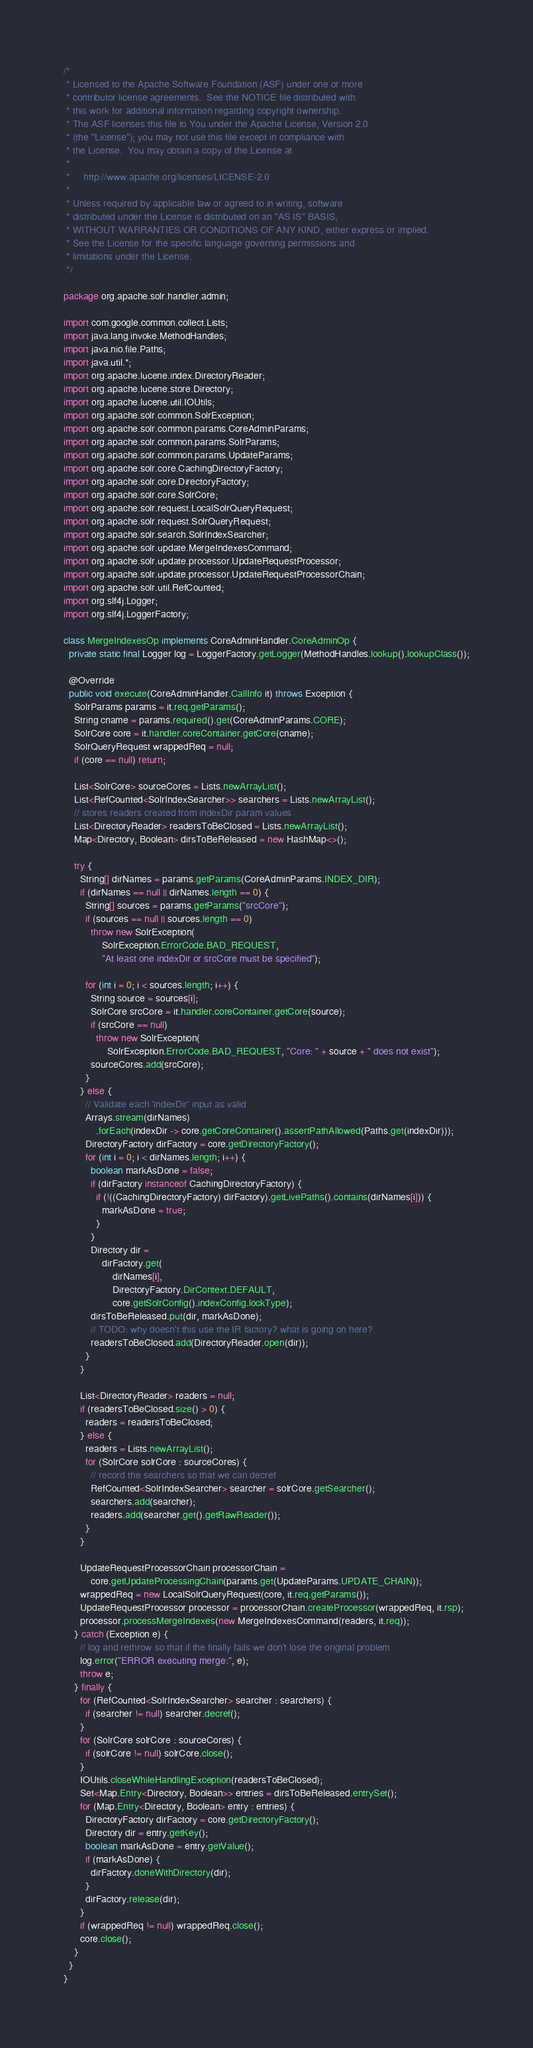<code> <loc_0><loc_0><loc_500><loc_500><_Java_>/*
 * Licensed to the Apache Software Foundation (ASF) under one or more
 * contributor license agreements.  See the NOTICE file distributed with
 * this work for additional information regarding copyright ownership.
 * The ASF licenses this file to You under the Apache License, Version 2.0
 * (the "License"); you may not use this file except in compliance with
 * the License.  You may obtain a copy of the License at
 *
 *     http://www.apache.org/licenses/LICENSE-2.0
 *
 * Unless required by applicable law or agreed to in writing, software
 * distributed under the License is distributed on an "AS IS" BASIS,
 * WITHOUT WARRANTIES OR CONDITIONS OF ANY KIND, either express or implied.
 * See the License for the specific language governing permissions and
 * limitations under the License.
 */

package org.apache.solr.handler.admin;

import com.google.common.collect.Lists;
import java.lang.invoke.MethodHandles;
import java.nio.file.Paths;
import java.util.*;
import org.apache.lucene.index.DirectoryReader;
import org.apache.lucene.store.Directory;
import org.apache.lucene.util.IOUtils;
import org.apache.solr.common.SolrException;
import org.apache.solr.common.params.CoreAdminParams;
import org.apache.solr.common.params.SolrParams;
import org.apache.solr.common.params.UpdateParams;
import org.apache.solr.core.CachingDirectoryFactory;
import org.apache.solr.core.DirectoryFactory;
import org.apache.solr.core.SolrCore;
import org.apache.solr.request.LocalSolrQueryRequest;
import org.apache.solr.request.SolrQueryRequest;
import org.apache.solr.search.SolrIndexSearcher;
import org.apache.solr.update.MergeIndexesCommand;
import org.apache.solr.update.processor.UpdateRequestProcessor;
import org.apache.solr.update.processor.UpdateRequestProcessorChain;
import org.apache.solr.util.RefCounted;
import org.slf4j.Logger;
import org.slf4j.LoggerFactory;

class MergeIndexesOp implements CoreAdminHandler.CoreAdminOp {
  private static final Logger log = LoggerFactory.getLogger(MethodHandles.lookup().lookupClass());

  @Override
  public void execute(CoreAdminHandler.CallInfo it) throws Exception {
    SolrParams params = it.req.getParams();
    String cname = params.required().get(CoreAdminParams.CORE);
    SolrCore core = it.handler.coreContainer.getCore(cname);
    SolrQueryRequest wrappedReq = null;
    if (core == null) return;

    List<SolrCore> sourceCores = Lists.newArrayList();
    List<RefCounted<SolrIndexSearcher>> searchers = Lists.newArrayList();
    // stores readers created from indexDir param values
    List<DirectoryReader> readersToBeClosed = Lists.newArrayList();
    Map<Directory, Boolean> dirsToBeReleased = new HashMap<>();

    try {
      String[] dirNames = params.getParams(CoreAdminParams.INDEX_DIR);
      if (dirNames == null || dirNames.length == 0) {
        String[] sources = params.getParams("srcCore");
        if (sources == null || sources.length == 0)
          throw new SolrException(
              SolrException.ErrorCode.BAD_REQUEST,
              "At least one indexDir or srcCore must be specified");

        for (int i = 0; i < sources.length; i++) {
          String source = sources[i];
          SolrCore srcCore = it.handler.coreContainer.getCore(source);
          if (srcCore == null)
            throw new SolrException(
                SolrException.ErrorCode.BAD_REQUEST, "Core: " + source + " does not exist");
          sourceCores.add(srcCore);
        }
      } else {
        // Validate each 'indexDir' input as valid
        Arrays.stream(dirNames)
            .forEach(indexDir -> core.getCoreContainer().assertPathAllowed(Paths.get(indexDir)));
        DirectoryFactory dirFactory = core.getDirectoryFactory();
        for (int i = 0; i < dirNames.length; i++) {
          boolean markAsDone = false;
          if (dirFactory instanceof CachingDirectoryFactory) {
            if (!((CachingDirectoryFactory) dirFactory).getLivePaths().contains(dirNames[i])) {
              markAsDone = true;
            }
          }
          Directory dir =
              dirFactory.get(
                  dirNames[i],
                  DirectoryFactory.DirContext.DEFAULT,
                  core.getSolrConfig().indexConfig.lockType);
          dirsToBeReleased.put(dir, markAsDone);
          // TODO: why doesn't this use the IR factory? what is going on here?
          readersToBeClosed.add(DirectoryReader.open(dir));
        }
      }

      List<DirectoryReader> readers = null;
      if (readersToBeClosed.size() > 0) {
        readers = readersToBeClosed;
      } else {
        readers = Lists.newArrayList();
        for (SolrCore solrCore : sourceCores) {
          // record the searchers so that we can decref
          RefCounted<SolrIndexSearcher> searcher = solrCore.getSearcher();
          searchers.add(searcher);
          readers.add(searcher.get().getRawReader());
        }
      }

      UpdateRequestProcessorChain processorChain =
          core.getUpdateProcessingChain(params.get(UpdateParams.UPDATE_CHAIN));
      wrappedReq = new LocalSolrQueryRequest(core, it.req.getParams());
      UpdateRequestProcessor processor = processorChain.createProcessor(wrappedReq, it.rsp);
      processor.processMergeIndexes(new MergeIndexesCommand(readers, it.req));
    } catch (Exception e) {
      // log and rethrow so that if the finally fails we don't lose the original problem
      log.error("ERROR executing merge:", e);
      throw e;
    } finally {
      for (RefCounted<SolrIndexSearcher> searcher : searchers) {
        if (searcher != null) searcher.decref();
      }
      for (SolrCore solrCore : sourceCores) {
        if (solrCore != null) solrCore.close();
      }
      IOUtils.closeWhileHandlingException(readersToBeClosed);
      Set<Map.Entry<Directory, Boolean>> entries = dirsToBeReleased.entrySet();
      for (Map.Entry<Directory, Boolean> entry : entries) {
        DirectoryFactory dirFactory = core.getDirectoryFactory();
        Directory dir = entry.getKey();
        boolean markAsDone = entry.getValue();
        if (markAsDone) {
          dirFactory.doneWithDirectory(dir);
        }
        dirFactory.release(dir);
      }
      if (wrappedReq != null) wrappedReq.close();
      core.close();
    }
  }
}
</code> 